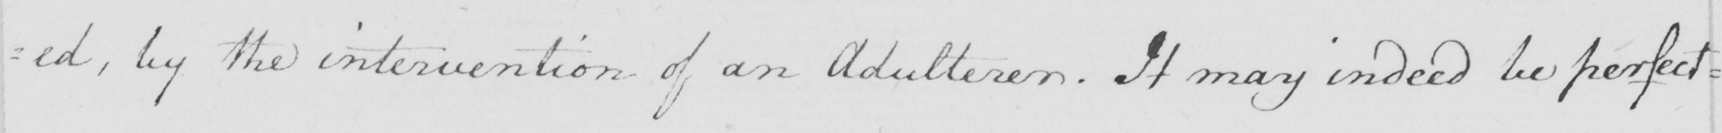Can you read and transcribe this handwriting? : ed , by the intervention of an Adulterer . It may indeed be perfect= 